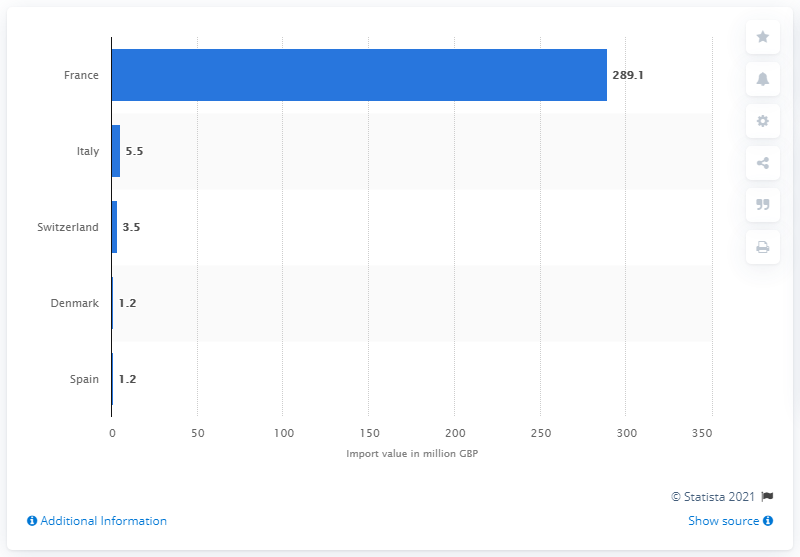Highlight a few significant elements in this photo. According to data from 2020, France was the country that imported the most champagne into the United Kingdom. 